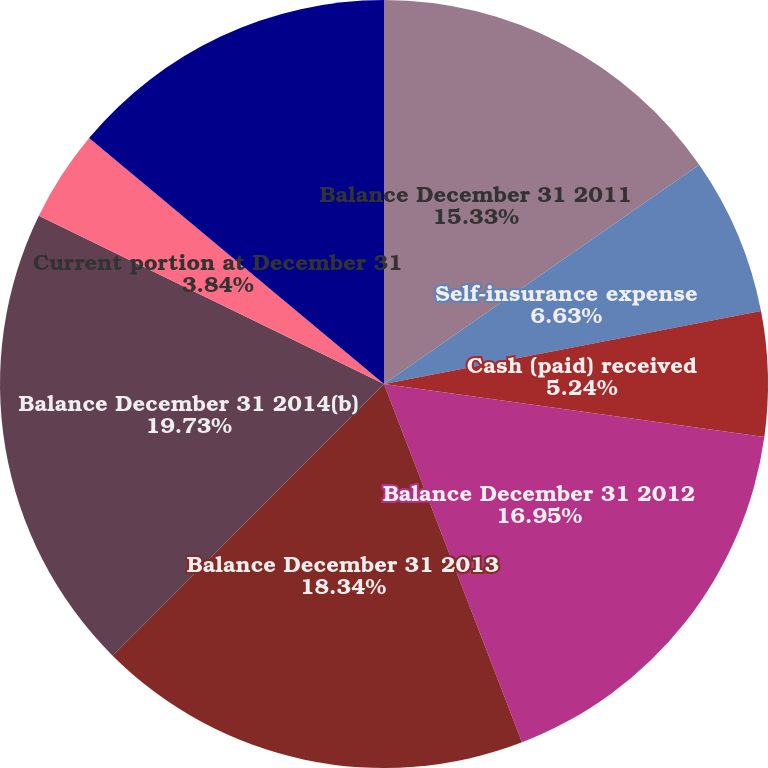<chart> <loc_0><loc_0><loc_500><loc_500><pie_chart><fcel>Balance December 31 2011<fcel>Self-insurance expense<fcel>Cash (paid) received<fcel>Balance December 31 2012<fcel>Balance December 31 2013<fcel>Balance December 31 2014(b)<fcel>Current portion at December 31<fcel>Long-term portion at December<nl><fcel>15.33%<fcel>6.63%<fcel>5.24%<fcel>16.95%<fcel>18.34%<fcel>19.73%<fcel>3.84%<fcel>13.94%<nl></chart> 